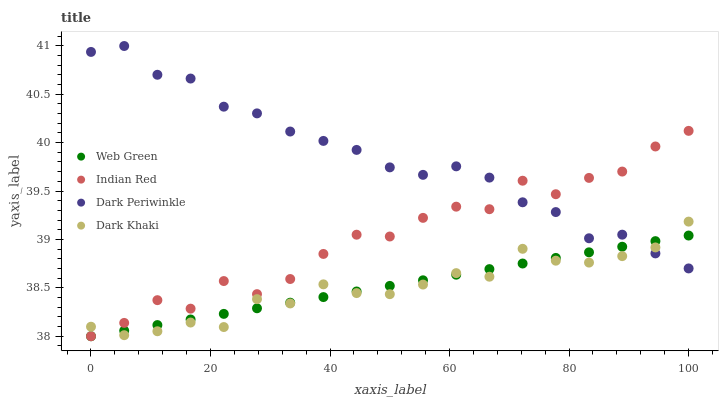Does Dark Khaki have the minimum area under the curve?
Answer yes or no. Yes. Does Dark Periwinkle have the maximum area under the curve?
Answer yes or no. Yes. Does Indian Red have the minimum area under the curve?
Answer yes or no. No. Does Indian Red have the maximum area under the curve?
Answer yes or no. No. Is Web Green the smoothest?
Answer yes or no. Yes. Is Indian Red the roughest?
Answer yes or no. Yes. Is Indian Red the smoothest?
Answer yes or no. No. Is Web Green the roughest?
Answer yes or no. No. Does Indian Red have the lowest value?
Answer yes or no. Yes. Does Dark Periwinkle have the lowest value?
Answer yes or no. No. Does Dark Periwinkle have the highest value?
Answer yes or no. Yes. Does Indian Red have the highest value?
Answer yes or no. No. Does Indian Red intersect Web Green?
Answer yes or no. Yes. Is Indian Red less than Web Green?
Answer yes or no. No. Is Indian Red greater than Web Green?
Answer yes or no. No. 